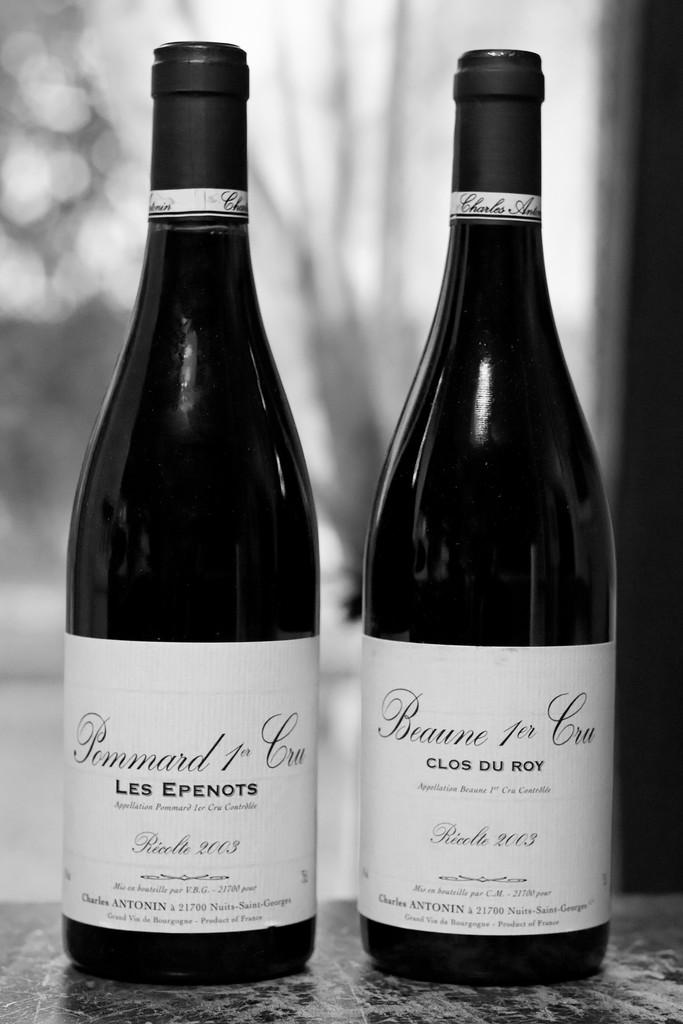<image>
Describe the image concisely. two bottles of Ricolte 2003 wine on a marble table 